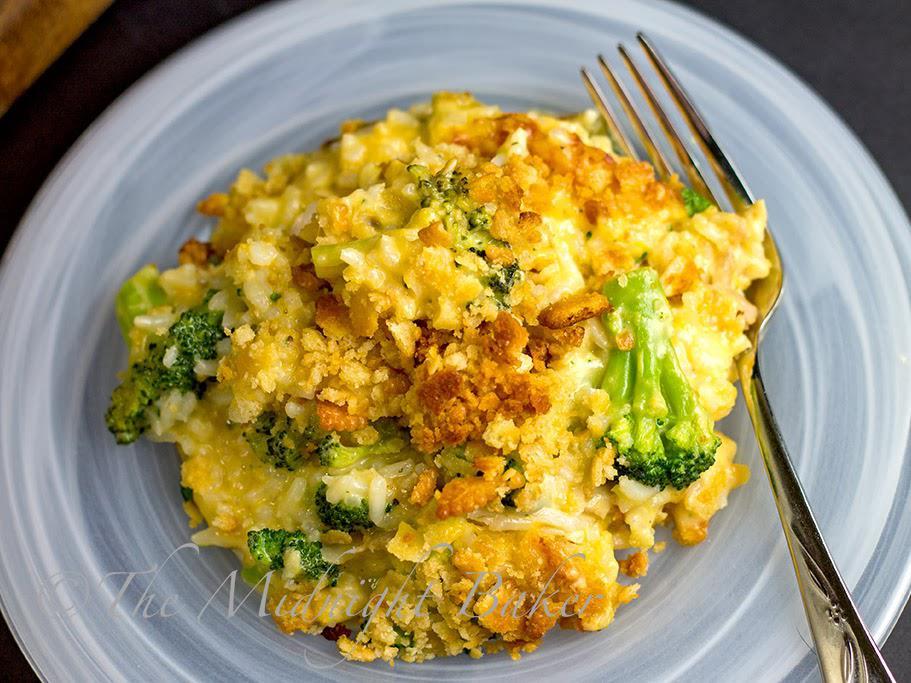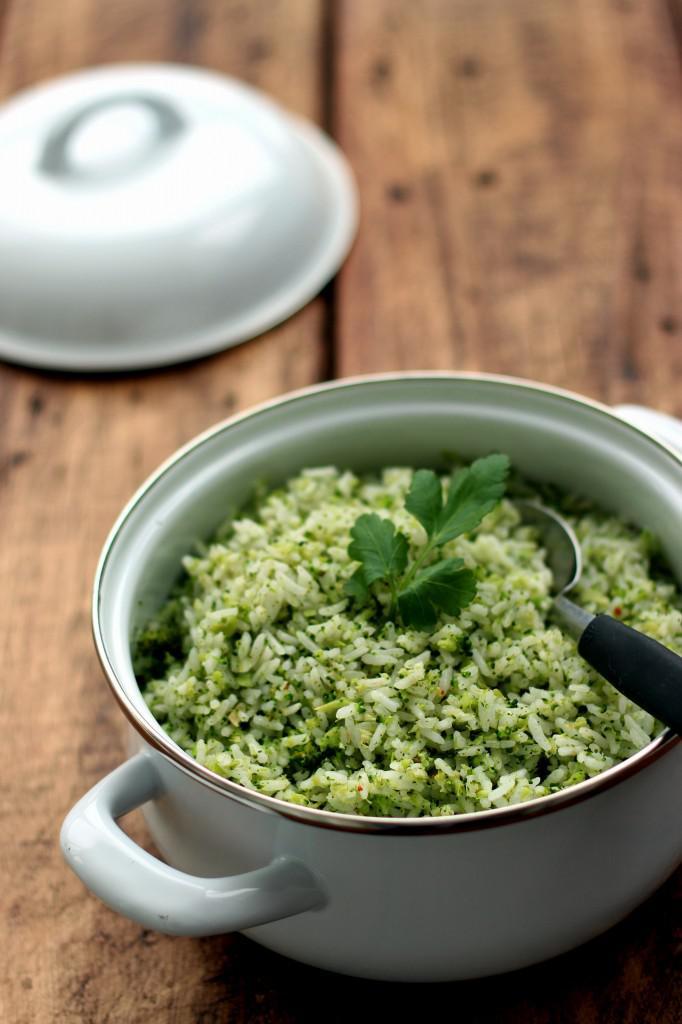The first image is the image on the left, the second image is the image on the right. For the images displayed, is the sentence "In one of the images there is a plate of broccoli casserole with a fork." factually correct? Answer yes or no. Yes. 